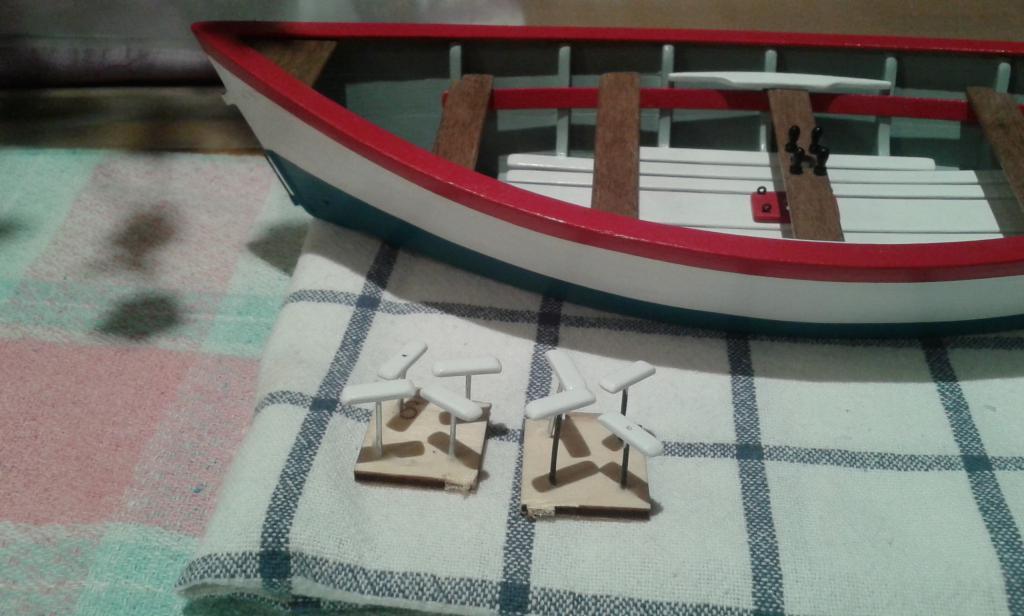In one or two sentences, can you explain what this image depicts? In this image I can see a boat which is in red, white, and gray color. 